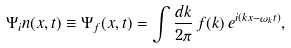Convert formula to latex. <formula><loc_0><loc_0><loc_500><loc_500>\Psi _ { i } n ( x , t ) \equiv \Psi _ { f } ( x , t ) = \int \frac { d k } { 2 \pi } \, f ( k ) \, e ^ { i ( k x - \omega _ { k } t ) } ,</formula> 